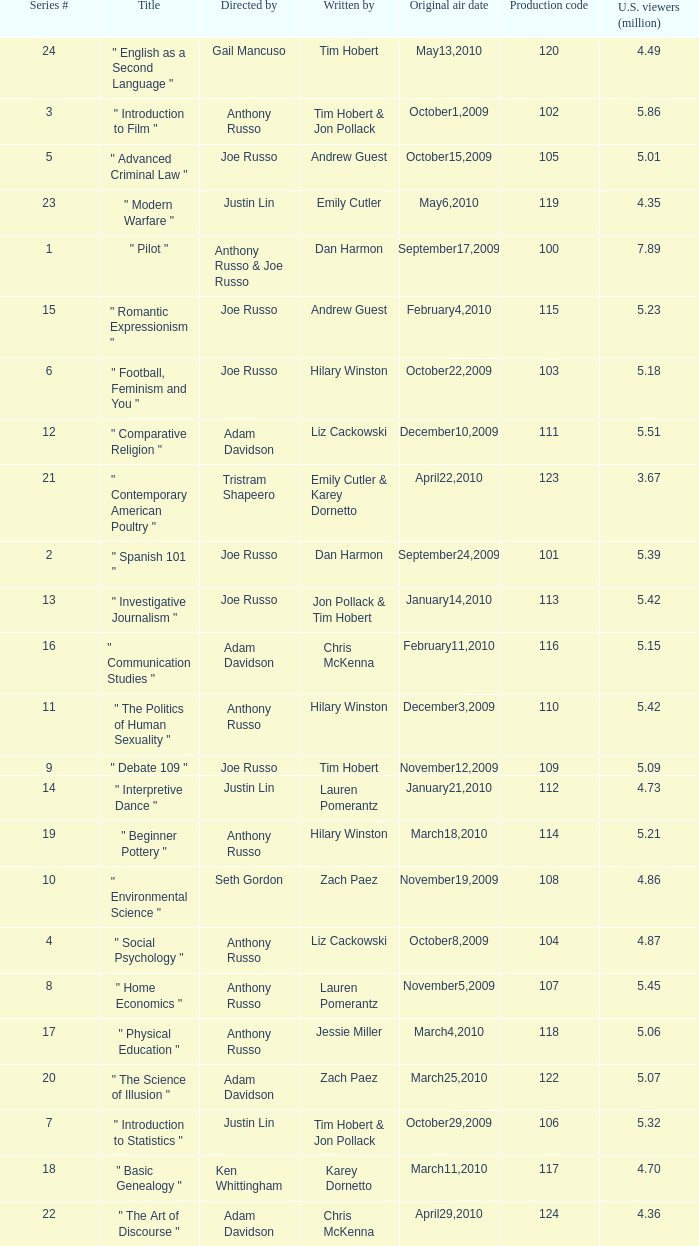What is the title of the series # 8? " Home Economics ". 